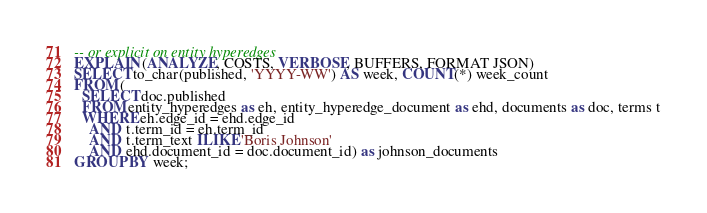Convert code to text. <code><loc_0><loc_0><loc_500><loc_500><_SQL_>-- or explicit on entity hyperedges
EXPLAIN (ANALYZE, COSTS, VERBOSE, BUFFERS, FORMAT JSON)
SELECT to_char(published, 'YYYY-WW') AS week, COUNT(*) week_count
FROM (
  SELECT doc.published
  FROM entity_hyperedges as eh, entity_hyperedge_document as ehd, documents as doc, terms t
  WHERE eh.edge_id = ehd.edge_id
    AND t.term_id = eh.term_id
    AND t.term_text ILIKE 'Boris Johnson'
    AND ehd.document_id = doc.document_id) as johnson_documents
GROUP BY week;
</code> 